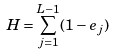<formula> <loc_0><loc_0><loc_500><loc_500>H = \sum _ { j = 1 } ^ { L - 1 } ( 1 - e _ { j } )</formula> 